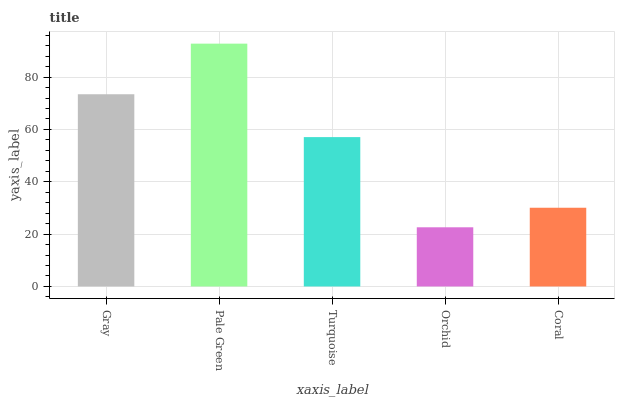Is Orchid the minimum?
Answer yes or no. Yes. Is Pale Green the maximum?
Answer yes or no. Yes. Is Turquoise the minimum?
Answer yes or no. No. Is Turquoise the maximum?
Answer yes or no. No. Is Pale Green greater than Turquoise?
Answer yes or no. Yes. Is Turquoise less than Pale Green?
Answer yes or no. Yes. Is Turquoise greater than Pale Green?
Answer yes or no. No. Is Pale Green less than Turquoise?
Answer yes or no. No. Is Turquoise the high median?
Answer yes or no. Yes. Is Turquoise the low median?
Answer yes or no. Yes. Is Coral the high median?
Answer yes or no. No. Is Pale Green the low median?
Answer yes or no. No. 